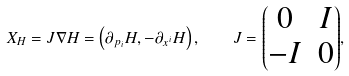Convert formula to latex. <formula><loc_0><loc_0><loc_500><loc_500>X _ { H } = J \nabla H = \left ( \partial _ { p _ { i } } H , - \partial _ { x ^ { i } } H \right ) , \quad J = { \left ( \begin{matrix} 0 & I \\ - I & 0 \end{matrix} \right ) } ,</formula> 